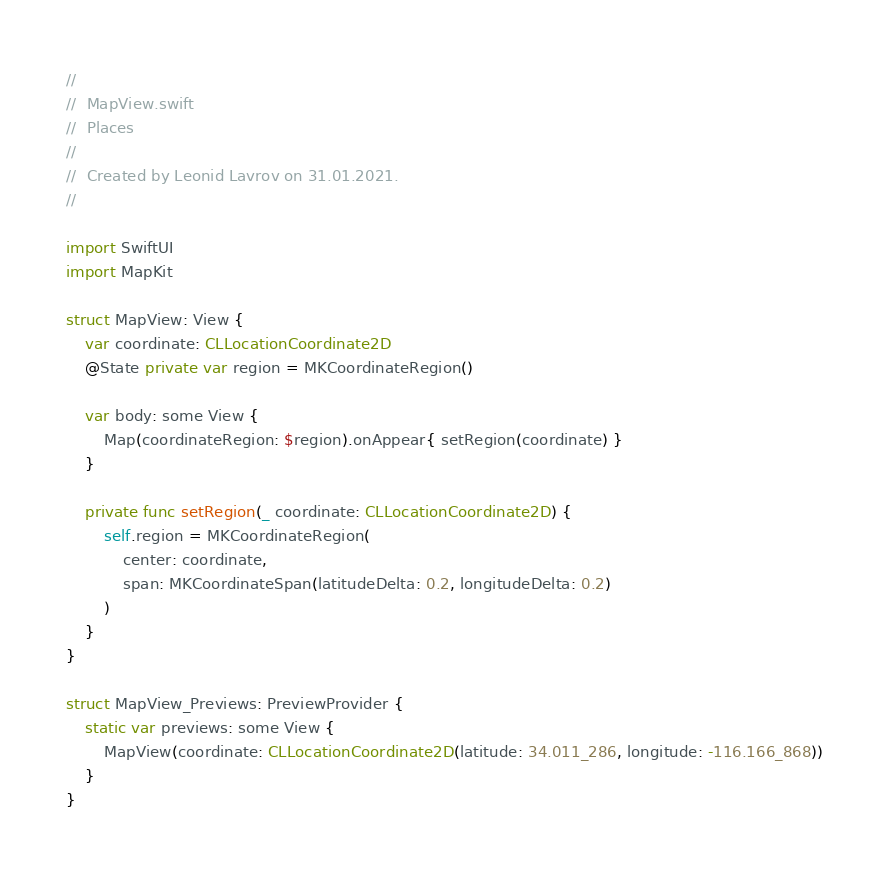Convert code to text. <code><loc_0><loc_0><loc_500><loc_500><_Swift_>//
//  MapView.swift
//  Places
//
//  Created by Leonid Lavrov on 31.01.2021.
//

import SwiftUI
import MapKit

struct MapView: View {
    var coordinate: CLLocationCoordinate2D
    @State private var region = MKCoordinateRegion()
    
    var body: some View {
        Map(coordinateRegion: $region).onAppear{ setRegion(coordinate) }
    }
    
    private func setRegion(_ coordinate: CLLocationCoordinate2D) {
        self.region = MKCoordinateRegion(
            center: coordinate,
            span: MKCoordinateSpan(latitudeDelta: 0.2, longitudeDelta: 0.2)
        )
    }
}

struct MapView_Previews: PreviewProvider {
    static var previews: some View {
        MapView(coordinate: CLLocationCoordinate2D(latitude: 34.011_286, longitude: -116.166_868))
    }
}
</code> 